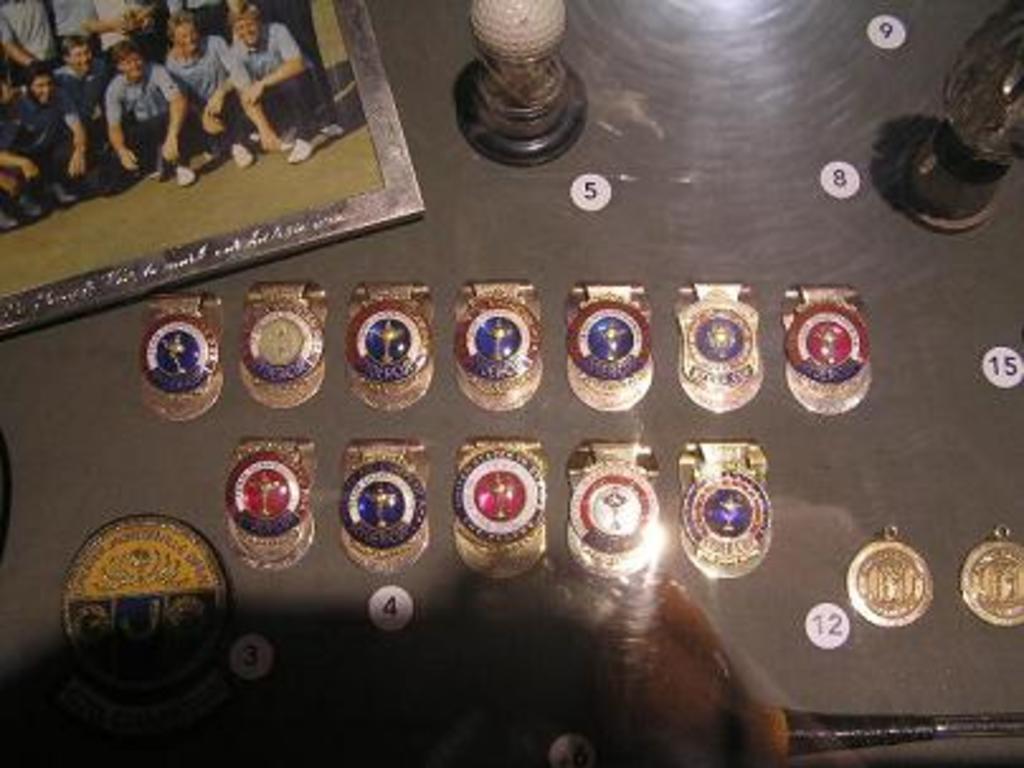What number is by the golf ball?
Your answer should be compact. 5. What number is written on the white circle furthest to the right?
Ensure brevity in your answer.  15. 